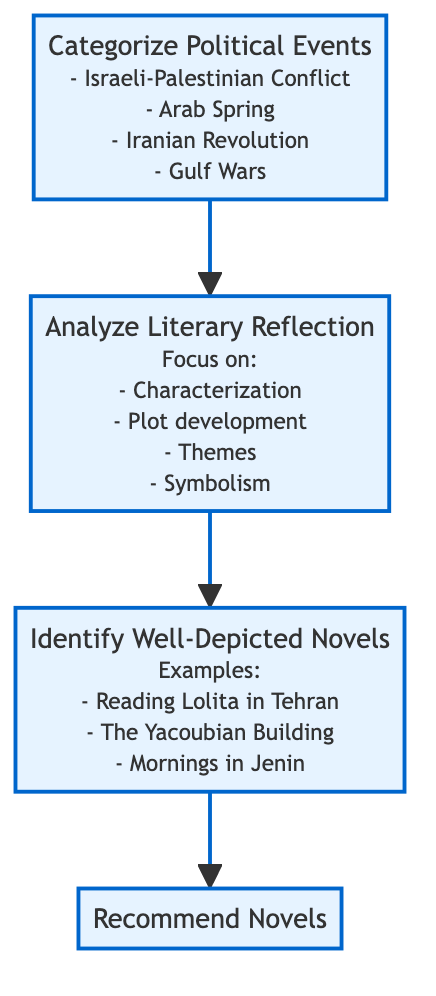What are the categories of political events? The diagram lists four categories under the "Categorize Political Events" node, which are clearly stated: Israeli-Palestinian Conflict, Arab Spring, Iranian Revolution, and Gulf Wars.
Answer: Israeli-Palestinian Conflict, Arab Spring, Iranian Revolution, Gulf Wars How many nodes are there in the flowchart? The flowchart consists of four nodes: "Categorize Political Events," "Analyze Literary Reflection," "Identify Well-Depicted Novels," and "Recommend Novels." Therefore, the total is calculated by counting each node in the diagram.
Answer: 4 What is the first step in the flowchart? The first node at the bottom of the flowchart is "Categorize Political Events," which indicates that this is the initial action in the sequence that leads to subsequent steps.
Answer: Categorize Political Events What is analyzed to reflect political events in literature? The "Analyze Literary Reflection" node outlines specific focuses that are analyzed, including characterization, plot development, themes, and symbolism. This indicates how political events intersect with literary elements.
Answer: Characterization, Plot development, Themes, Symbolism Which node follows "Analyze Literary Reflection"? According to the directional flow indicated by the arrows, the node that follows "Analyze Literary Reflection" is "Identify Well-Depicted Novels," showing the progression in the sequence of actions within the diagram.
Answer: Identify Well-Depicted Novels What do the arrows indicate in this diagram? The arrows in the flowchart connect each node sequentially, indicating the direction of the process flow from "Categorize Political Events" at the bottom to "Recommend Novels" at the top, demonstrating the logical progression of steps.
Answer: Direction of the process flow How are novels selected for recommendation? The recommendation process begins by identifying novels that effectively depict specific political events, showing that the selection is based on their accuracy and effectiveness as displayed in the "Identify Well-Depicted Novels" node.
Answer: Based on accuracy and effectiveness What is the final action in the flowchart? The last node in the flowchart, at the top, is "Recommend Novels," which signifies that this is the outcome of the entire flow, culminating from the previous steps in the diagram.
Answer: Recommend Novels 